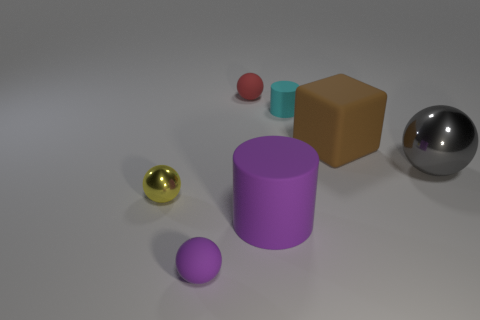Subtract all big shiny balls. How many balls are left? 3 Add 3 gray metal objects. How many objects exist? 10 Subtract 1 cubes. How many cubes are left? 0 Subtract all cyan cylinders. How many cylinders are left? 1 Subtract 0 red cylinders. How many objects are left? 7 Subtract all cylinders. How many objects are left? 5 Subtract all red spheres. Subtract all gray blocks. How many spheres are left? 3 Subtract all brown blocks. How many purple balls are left? 1 Subtract all red matte things. Subtract all large rubber cylinders. How many objects are left? 5 Add 1 small red rubber things. How many small red rubber things are left? 2 